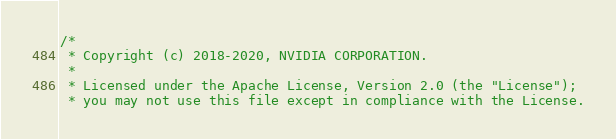Convert code to text. <code><loc_0><loc_0><loc_500><loc_500><_Cuda_>/*
 * Copyright (c) 2018-2020, NVIDIA CORPORATION.
 *
 * Licensed under the Apache License, Version 2.0 (the "License");
 * you may not use this file except in compliance with the License.</code> 